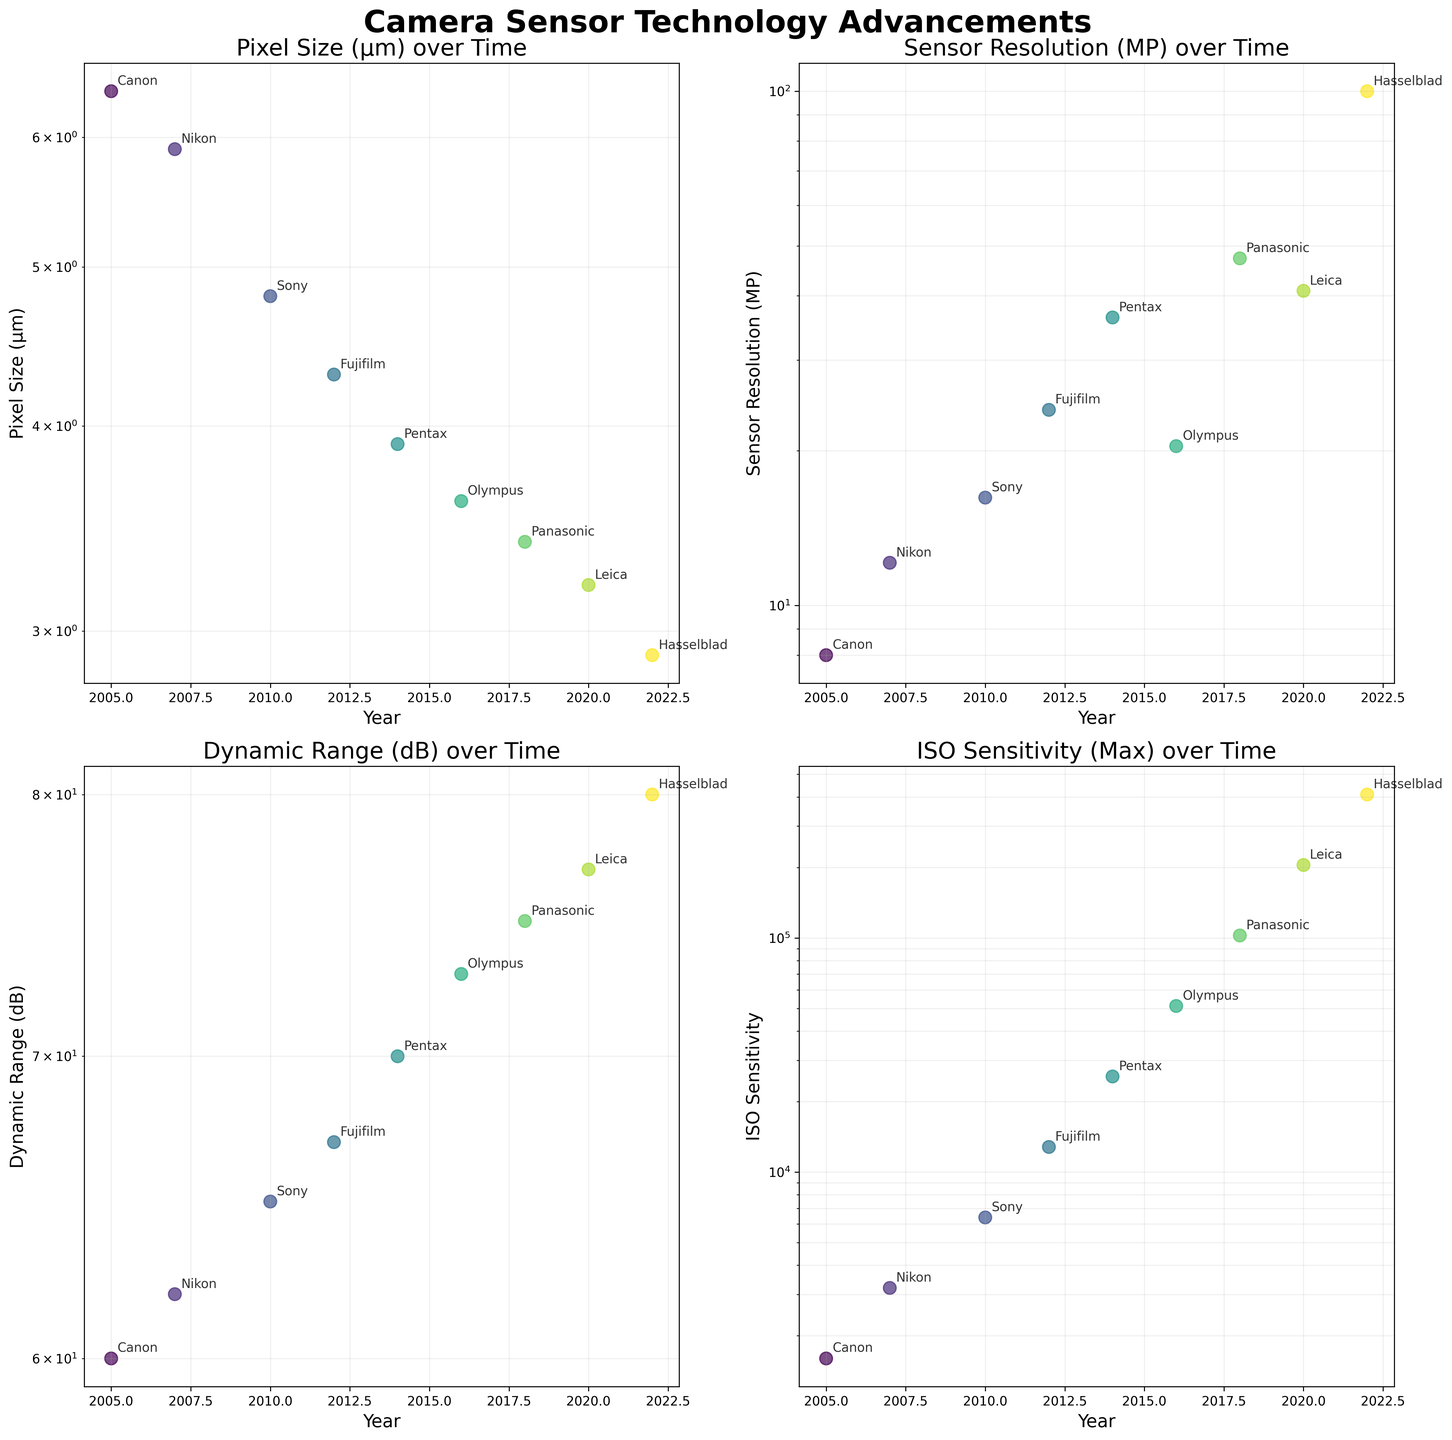What's the title of the figure? The title is located at the top of the figure in bold and large font. It is "Camera Sensor Technology Advancements".
Answer: Camera Sensor Technology Advancements How many subplots are there in the figure? By looking at the layout of the figure, we see it has 4 separate plots arranged in a 2x2 grid.
Answer: 4 Which manufacturer had the smallest pixel size in 2022? On the subplot titled "Pixel Size (µm) over Time", locate the data point for the year 2022. The annotated label next to this point shows the manufacturer is Hasselblad.
Answer: Hasselblad In which year did the sensor resolution first exceed 20 Megapixels? On the subplot titled "Sensor Resolution (MP) over Time", identify the first year where a data point crosses the 20 MP line. According to the plot, this happens in the year 2012.
Answer: 2012 Compare the dynamic range of sensors between Nikon in 2007 and Leica in 2020. Which one has a higher value? Look at the subplot titled "Dynamic Range (dB) over Time" and compare the dynamic range values for Nikon in 2007 and Leica in 2020. Leica in 2020 has a higher dynamic range with 77 dB compared to Nikon's 62 dB in 2007.
Answer: Leica in 2020 What is the maximum ISO sensitivity reached by any manufacturer until 2018? On the subplot titled "ISO Sensitivity over Time", identify the highest data point up to the year 2018. The highest ISO sensitivity reached is 102400 by Panasonic in 2018.
Answer: 102400 Which manufacturer achieved the highest dynamic range and in what year? On the subplot titled "Dynamic Range (dB) over Time", identify the highest data point. The highest dynamic range value is 80 dB achieved by Hasselblad in 2022.
Answer: Hasselblad in 2022 What is the general trend in pixel size from 2005 to 2022? Observe the subplot titled "Pixel Size (µm) over Time". The general trend shows a consistent decrease in pixel size from 6.4 µm in 2005 to 2.9 µm in 2022.
Answer: Decreasing From 2010 to 2018, how did the sensor resolution of Sony compare to Panasonic? On the subplot titled "Sensor Resolution (MP) over Time", compare Sony's resolution in 2010 (16.2 MP) with Panasonic's in 2018 (47.3 MP). Panasonic's resolution is higher.
Answer: Panasonic's resolution is higher Is there any correlation visible between the year and the dynamic range values? By looking at the subplot titled "Dynamic Range (dB) over Time", the dynamic range values generally increase over the years from 2005 to 2022, indicating a positive correlation.
Answer: Positive correlation 